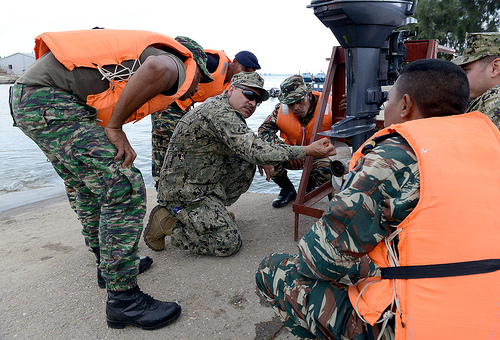<image>
Is the hat on the man? No. The hat is not positioned on the man. They may be near each other, but the hat is not supported by or resting on top of the man. 